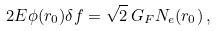<formula> <loc_0><loc_0><loc_500><loc_500>2 E \phi ( r _ { 0 } ) \delta f = \sqrt { 2 } \, G _ { F } N _ { e } ( r _ { 0 } ) \, ,</formula> 